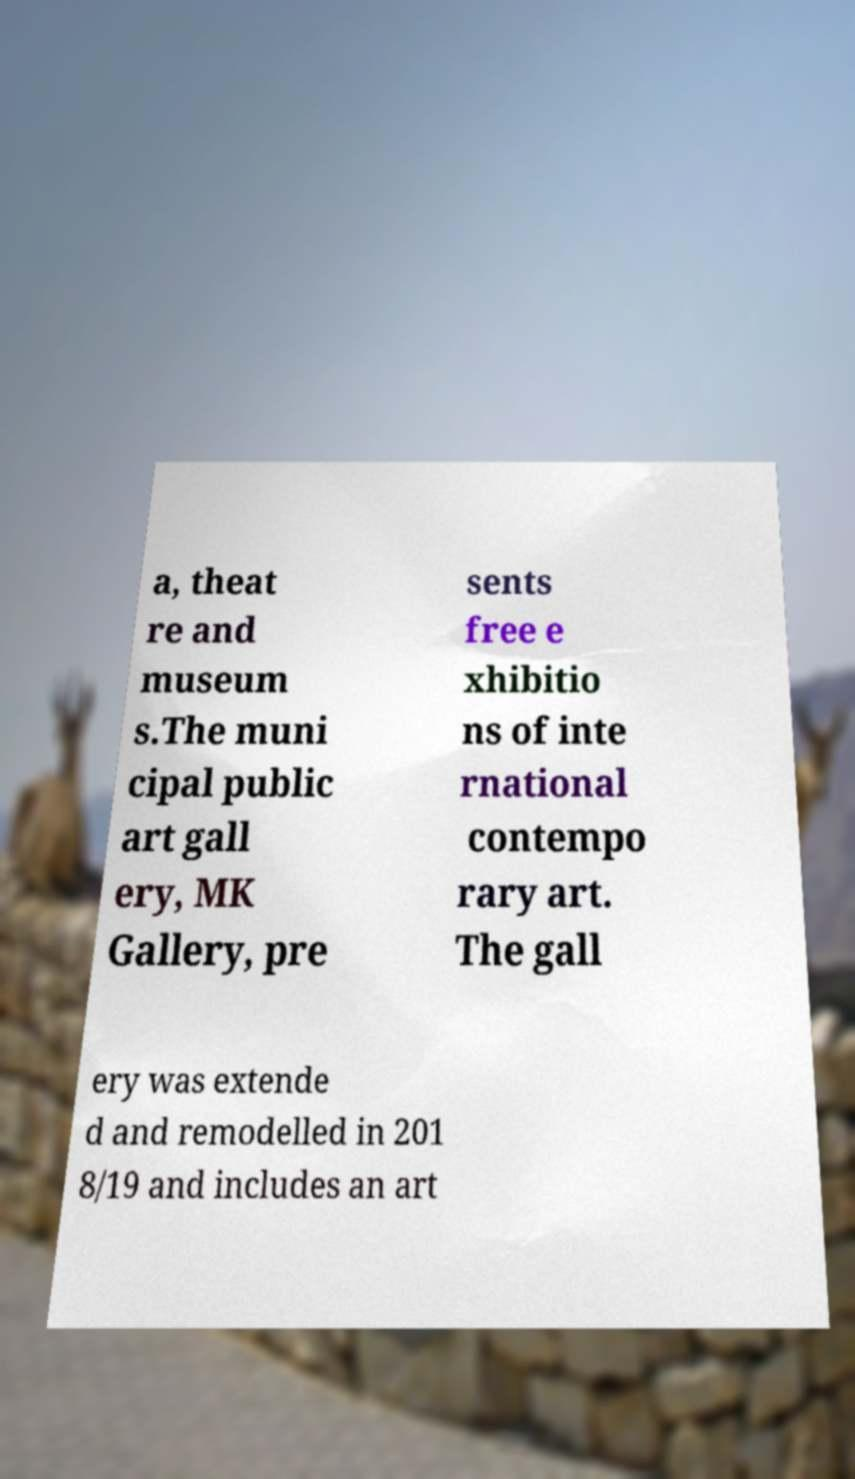Please read and relay the text visible in this image. What does it say? a, theat re and museum s.The muni cipal public art gall ery, MK Gallery, pre sents free e xhibitio ns of inte rnational contempo rary art. The gall ery was extende d and remodelled in 201 8/19 and includes an art 